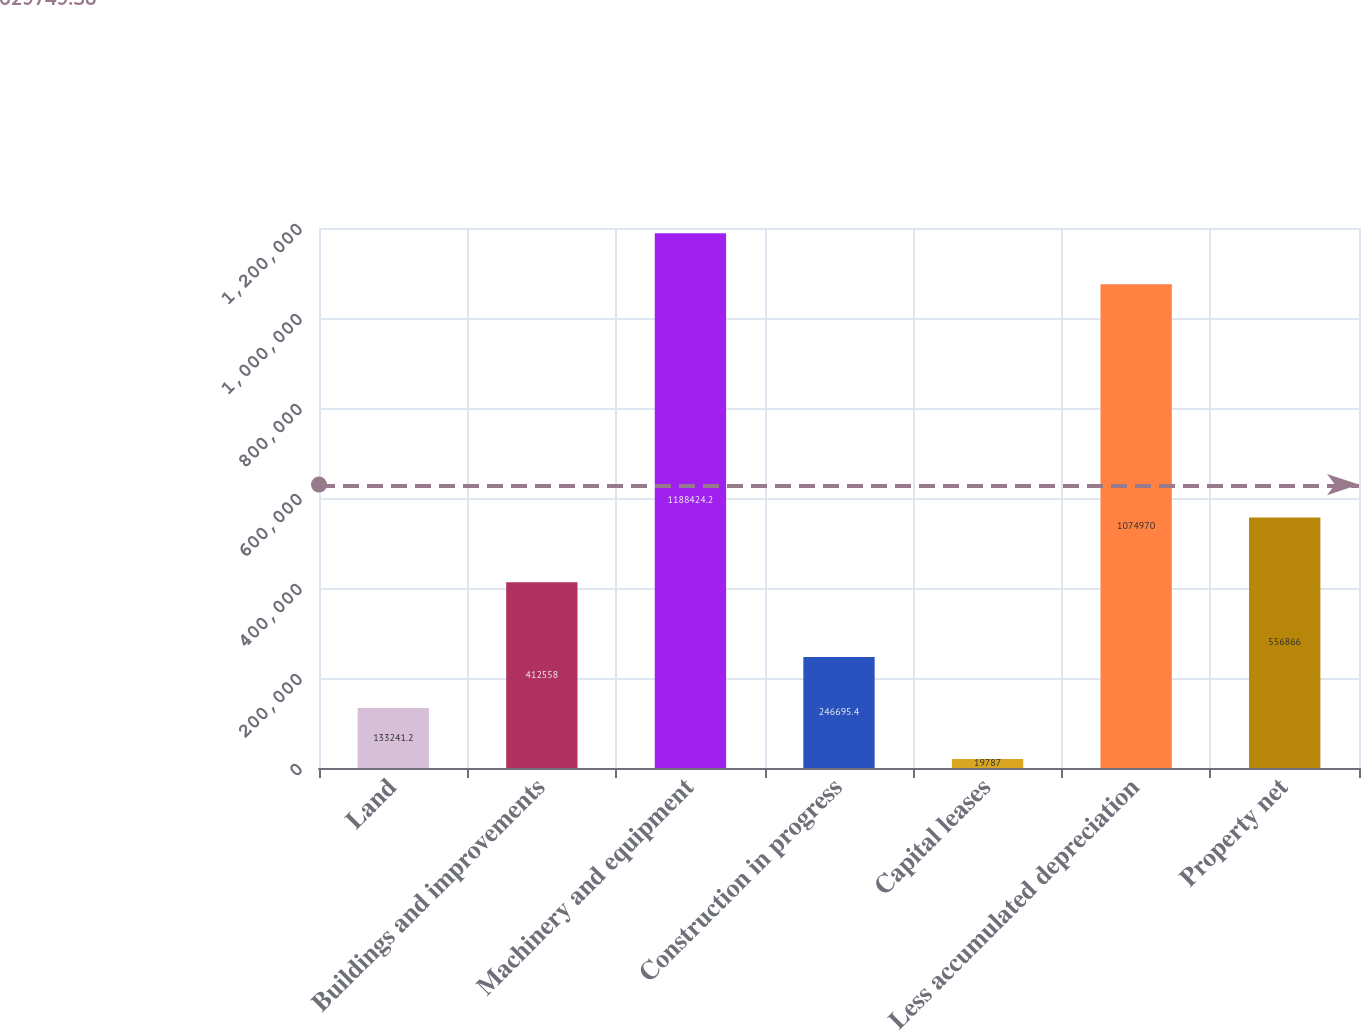Convert chart to OTSL. <chart><loc_0><loc_0><loc_500><loc_500><bar_chart><fcel>Land<fcel>Buildings and improvements<fcel>Machinery and equipment<fcel>Construction in progress<fcel>Capital leases<fcel>Less accumulated depreciation<fcel>Property net<nl><fcel>133241<fcel>412558<fcel>1.18842e+06<fcel>246695<fcel>19787<fcel>1.07497e+06<fcel>556866<nl></chart> 